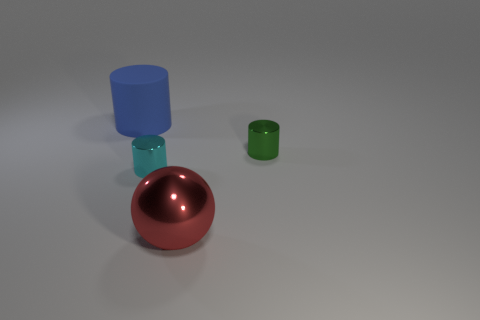Is there anything else that is the same shape as the big metallic thing?
Make the answer very short. No. Is there any other thing that has the same material as the large blue thing?
Give a very brief answer. No. Is the number of cylinders greater than the number of tiny red metal things?
Your answer should be very brief. Yes. How many things are either large brown shiny blocks or green cylinders right of the large metallic ball?
Ensure brevity in your answer.  1. Do the rubber object and the green shiny cylinder have the same size?
Offer a terse response. No. There is a rubber object; are there any cyan objects in front of it?
Make the answer very short. Yes. What size is the thing that is to the left of the green cylinder and behind the cyan metal cylinder?
Make the answer very short. Large. What number of things are either blue cylinders or yellow balls?
Keep it short and to the point. 1. There is a cyan shiny object; does it have the same size as the metal cylinder that is to the right of the large red thing?
Offer a terse response. Yes. There is a matte thing that is to the left of the shiny thing right of the large object in front of the big rubber cylinder; how big is it?
Your answer should be compact. Large. 